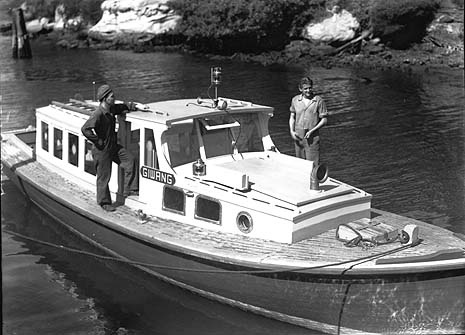Describe the objects in this image and their specific colors. I can see boat in gray, white, black, and darkgray tones, people in gray, black, darkgray, and lightgray tones, and people in gray, darkgray, black, and gainsboro tones in this image. 